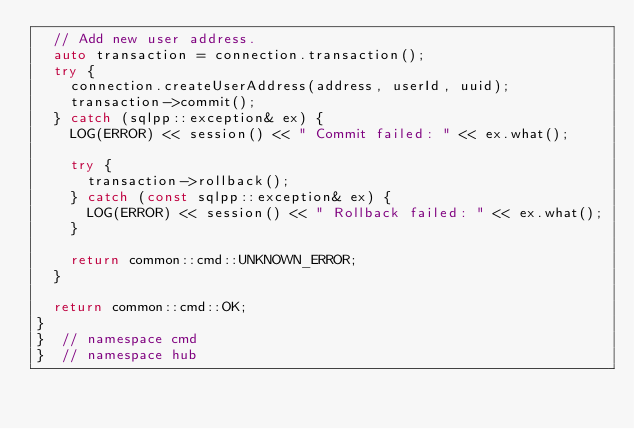<code> <loc_0><loc_0><loc_500><loc_500><_C++_>  // Add new user address.
  auto transaction = connection.transaction();
  try {
    connection.createUserAddress(address, userId, uuid);
    transaction->commit();
  } catch (sqlpp::exception& ex) {
    LOG(ERROR) << session() << " Commit failed: " << ex.what();

    try {
      transaction->rollback();
    } catch (const sqlpp::exception& ex) {
      LOG(ERROR) << session() << " Rollback failed: " << ex.what();
    }

    return common::cmd::UNKNOWN_ERROR;
  }

  return common::cmd::OK;
}
}  // namespace cmd
}  // namespace hub
</code> 